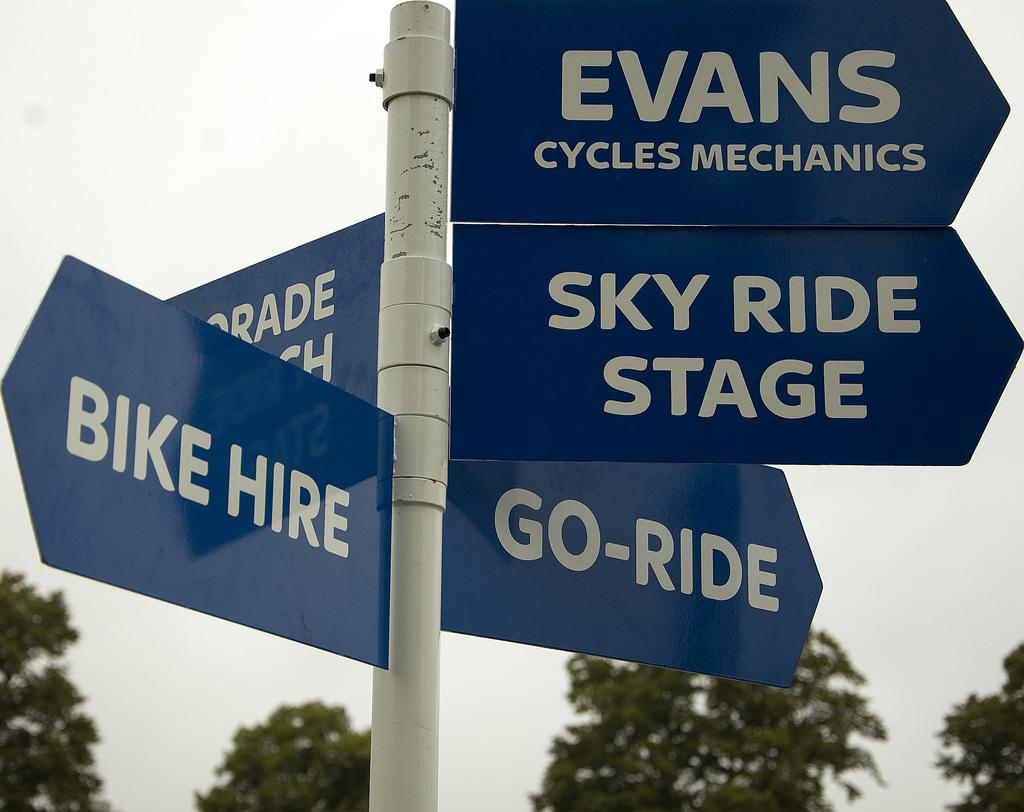<image>
Render a clear and concise summary of the photo. Direction signs point the way to Evans Cycles Mechanics, Sky Ride Stage, Go-Ride, and Bike Hire. 